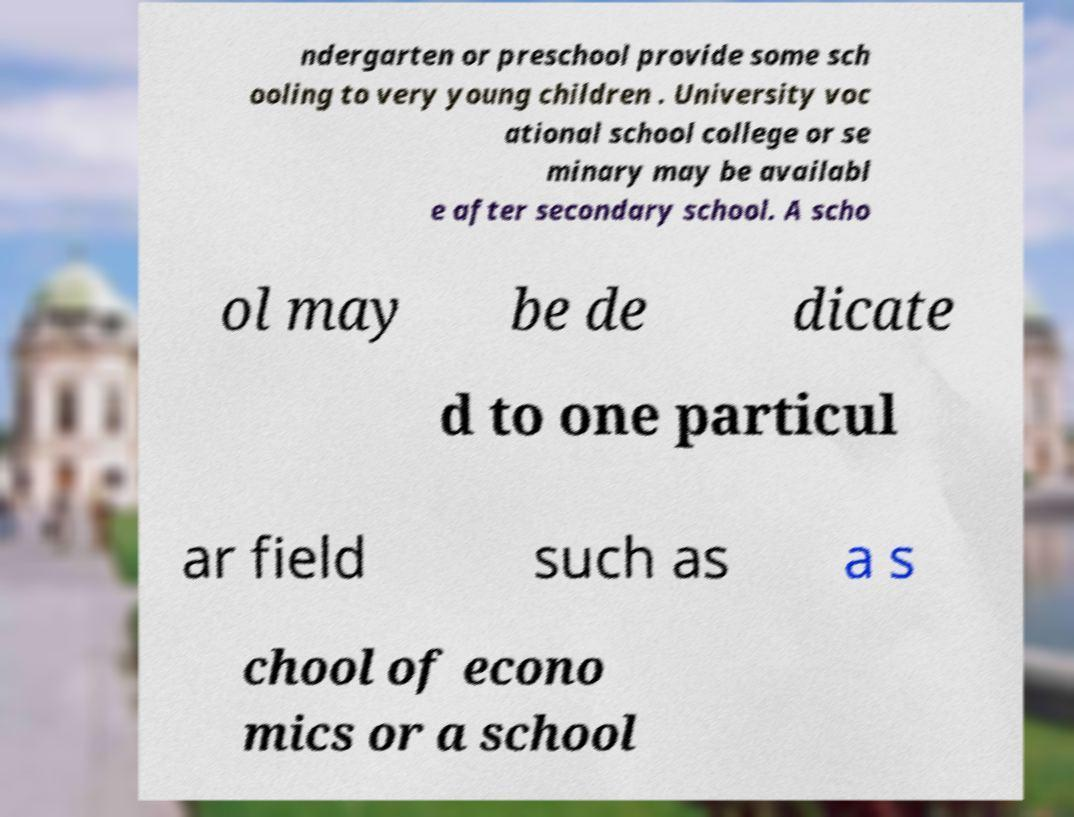Can you accurately transcribe the text from the provided image for me? ndergarten or preschool provide some sch ooling to very young children . University voc ational school college or se minary may be availabl e after secondary school. A scho ol may be de dicate d to one particul ar field such as a s chool of econo mics or a school 